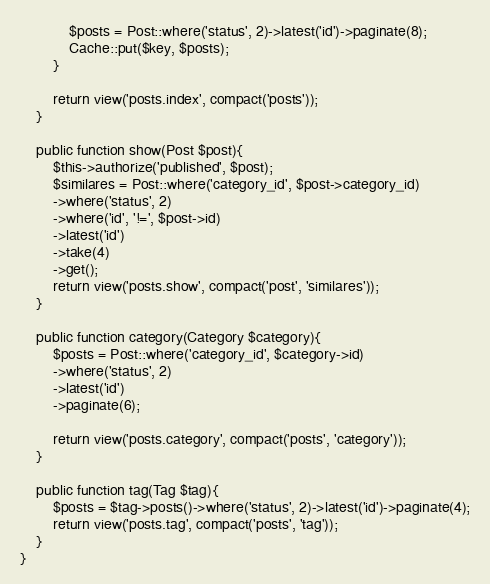Convert code to text. <code><loc_0><loc_0><loc_500><loc_500><_PHP_>            $posts = Post::where('status', 2)->latest('id')->paginate(8);
            Cache::put($key, $posts);
        }
        
        return view('posts.index', compact('posts'));
    }

    public function show(Post $post){
        $this->authorize('published', $post);
        $similares = Post::where('category_id', $post->category_id)
        ->where('status', 2)
        ->where('id', '!=', $post->id)
        ->latest('id')
        ->take(4)
        ->get();
        return view('posts.show', compact('post', 'similares'));
    }

    public function category(Category $category){
        $posts = Post::where('category_id', $category->id)
        ->where('status', 2)
        ->latest('id')
        ->paginate(6);

        return view('posts.category', compact('posts', 'category'));
    }

    public function tag(Tag $tag){
        $posts = $tag->posts()->where('status', 2)->latest('id')->paginate(4);
        return view('posts.tag', compact('posts', 'tag'));
    }
}
</code> 